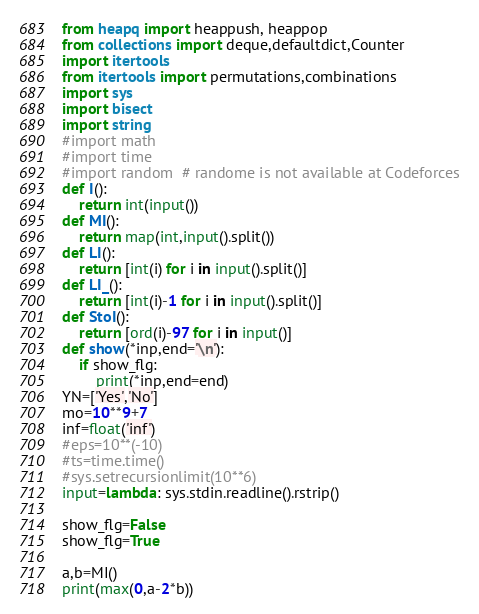<code> <loc_0><loc_0><loc_500><loc_500><_Python_>from heapq import heappush, heappop
from collections import deque,defaultdict,Counter
import itertools
from itertools import permutations,combinations
import sys
import bisect
import string
#import math
#import time
#import random  # randome is not available at Codeforces
def I():
    return int(input())
def MI():
    return map(int,input().split())
def LI():
    return [int(i) for i in input().split()]
def LI_():
    return [int(i)-1 for i in input().split()]
def StoI():
    return [ord(i)-97 for i in input()]
def show(*inp,end='\n'):
    if show_flg:
        print(*inp,end=end)
YN=['Yes','No']
mo=10**9+7
inf=float('inf')
#eps=10**(-10)
#ts=time.time()
#sys.setrecursionlimit(10**6)
input=lambda: sys.stdin.readline().rstrip()

show_flg=False
show_flg=True

a,b=MI()
print(max(0,a-2*b))
</code> 